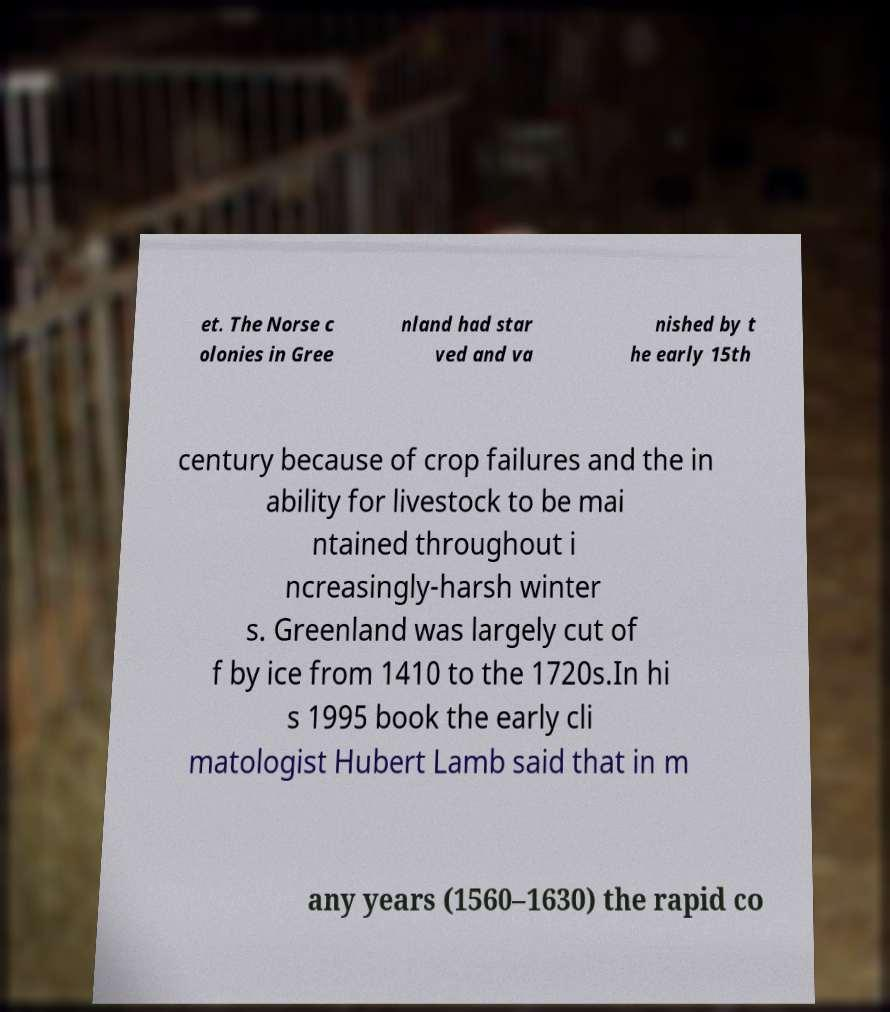Could you extract and type out the text from this image? et. The Norse c olonies in Gree nland had star ved and va nished by t he early 15th century because of crop failures and the in ability for livestock to be mai ntained throughout i ncreasingly-harsh winter s. Greenland was largely cut of f by ice from 1410 to the 1720s.In hi s 1995 book the early cli matologist Hubert Lamb said that in m any years (1560–1630) the rapid co 